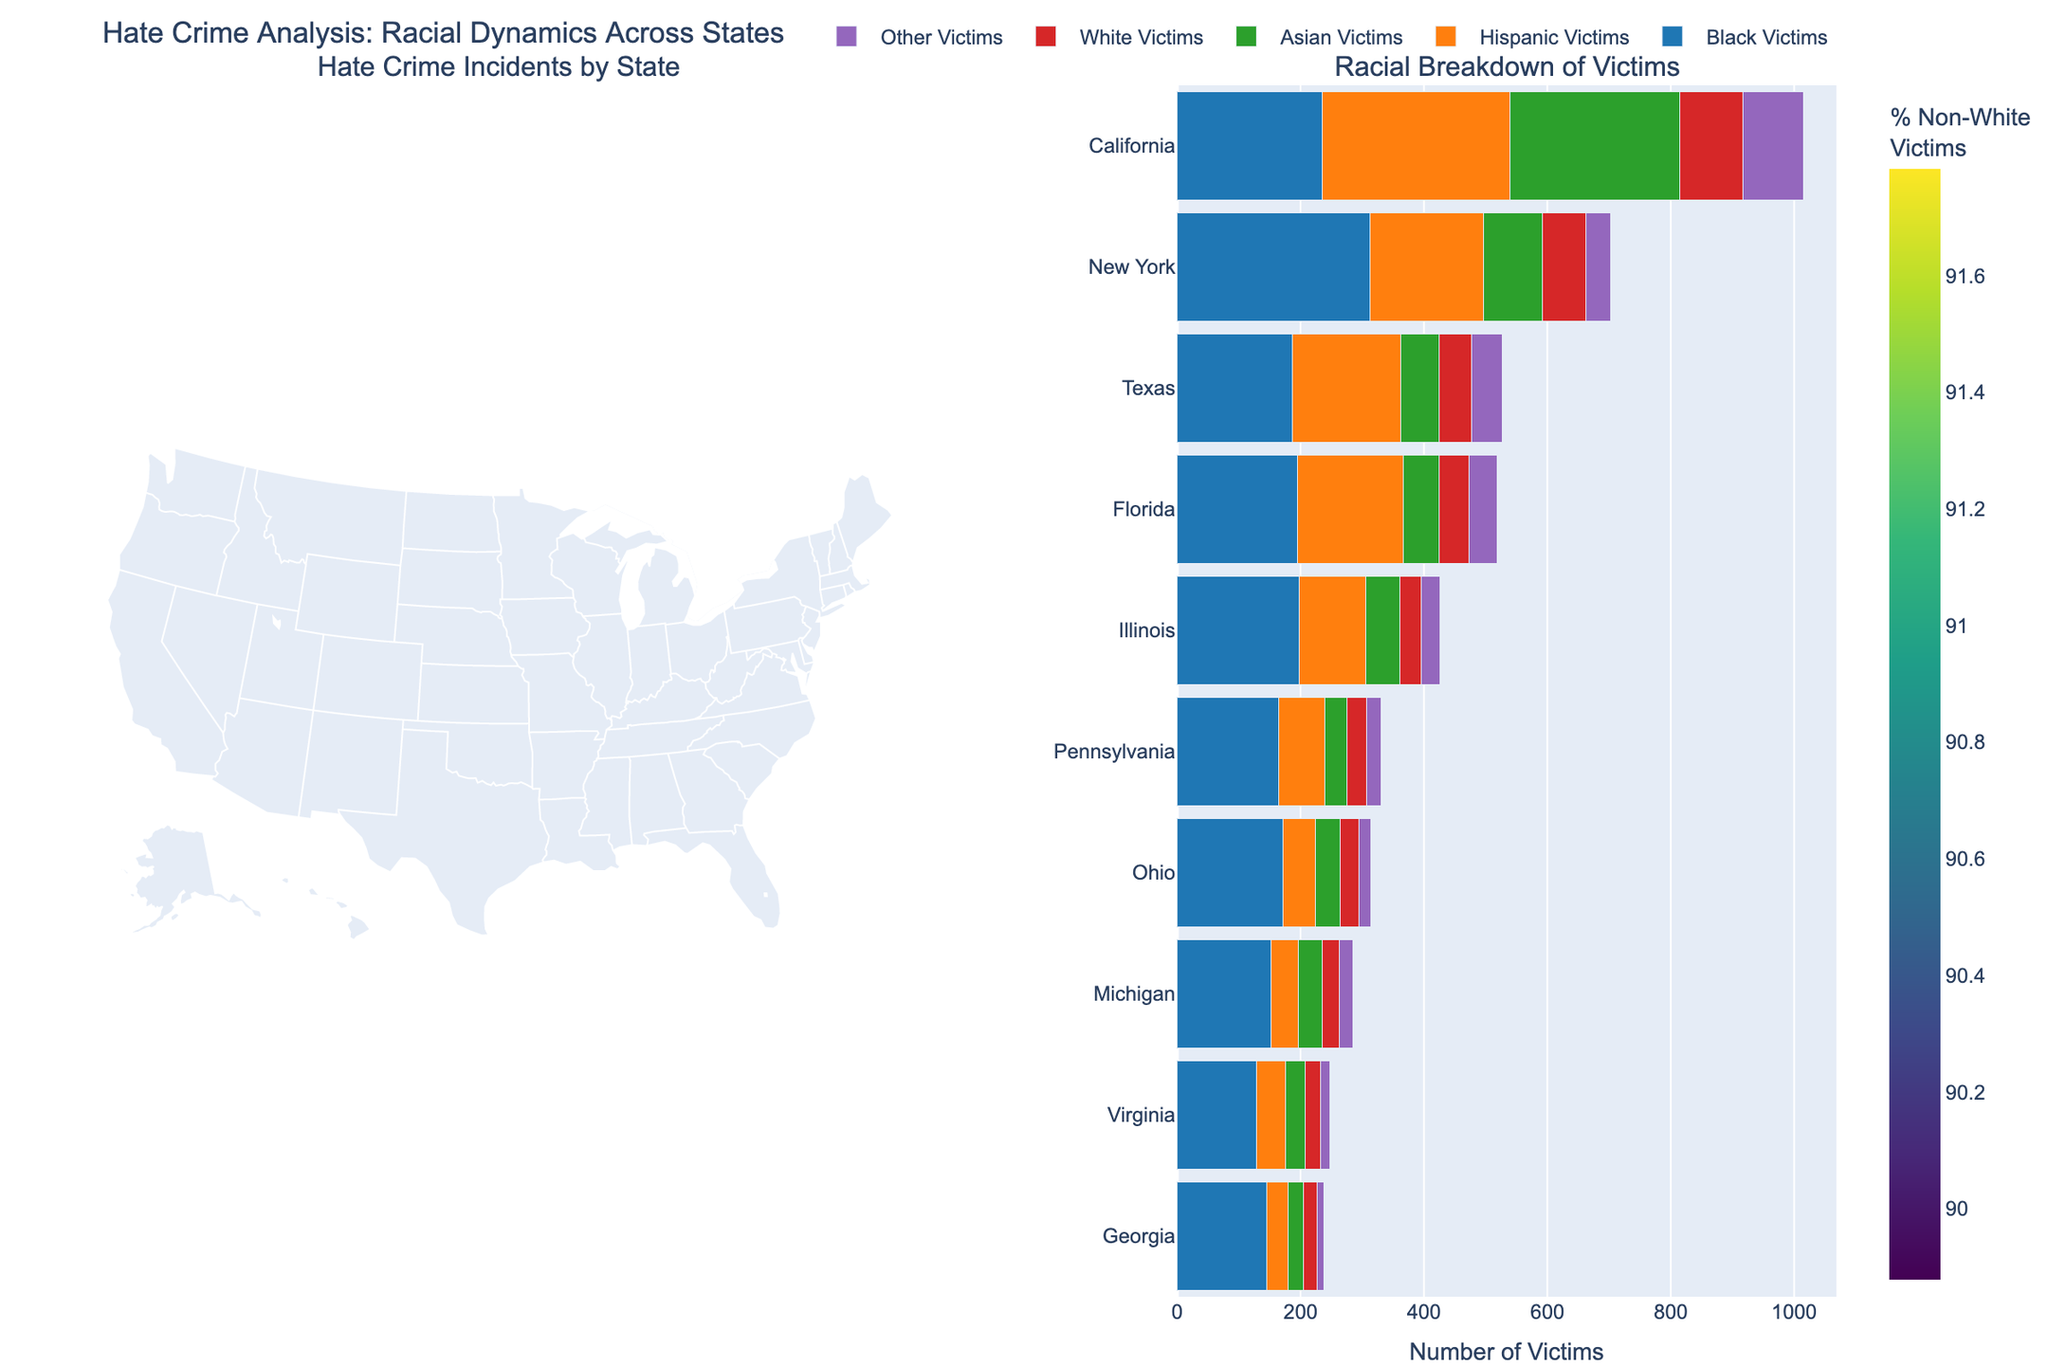What is the title of the figure? The title can be found at the top of the figure. Look for a bold or prominent text that describes the overall theme of the visualization.
Answer: Hate Crime Analysis: Racial Dynamics Across States Which state has the highest percentage of non-white victims in hate crimes? The choropleth map on the left side of the figure uses color intensity to indicate the percentage of non-white victims. The state with the darkest shade corresponds to the highest percentage.
Answer: New York How many total hate crime incidents were reported in California? According to the text associated with the state on the choropleth map, the total number of incidents is displayed when hovering over California.
Answer: 1015 What is the color scale used for the choropleth map? The color scale can be identified by the gradient bar next to the choropleth map that represents different percentage values. Look for the name or color scheme on the bar.
Answer: Viridis Which racial group is most frequently targeted in Texas? On the stacked bar chart, each bar segment represents different racial groups. The largest segment in the bar for Texas indicates the most frequently targeted racial group.
Answer: Black Victims What is the combined total number of Hispanic and Asian victims in Florida? Add the values of the Hispanic and Asian victims segments for Florida from the stacked bar chart. Hispanic Victims: 172 and Asian Victims: 58.
Answer: 230 Compare the number of Black victims in Illinois and Georgia. Which state has more? On the stacked bar chart, compare the sections corresponding to Black victims for both Illinois and Georgia. Identify the larger segment.
Answer: Illinois What is the range of the percentage of non-white victims across all states? The color bar next to the choropleth map indicates the minimum and maximum percentages. Look for the numeric values at both ends of the bar.
Answer: Approximately 70% to 95% Which state shows the lowest number of total hate crime incidents? By examining the heights of the total incidents bars on the stacked bar chart, determine the state with the shortest bar, which represents the lowest total incidents.
Answer: Georgia What percentage of hate crime victims are non-white in Pennsylvania? According to the choropleth map, hover over Pennsylvania to reveal detailed data, including the exact percentage of non-white victims.
Answer: 90% 